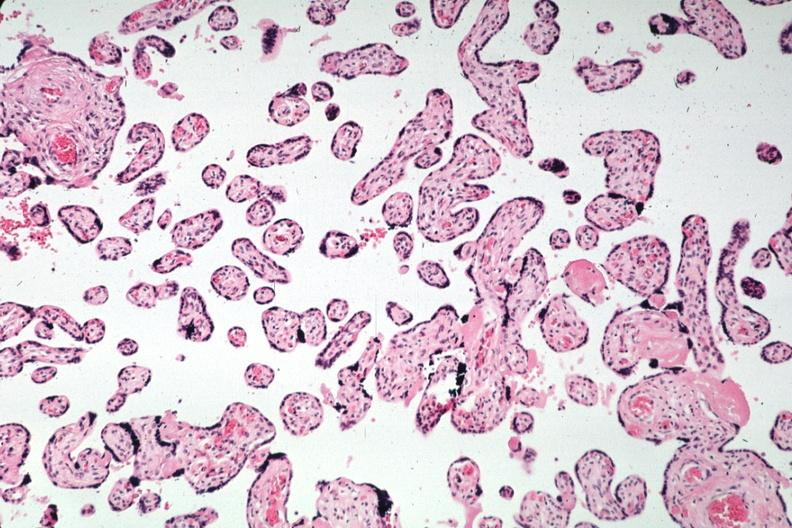s pus in test tube present?
Answer the question using a single word or phrase. No 